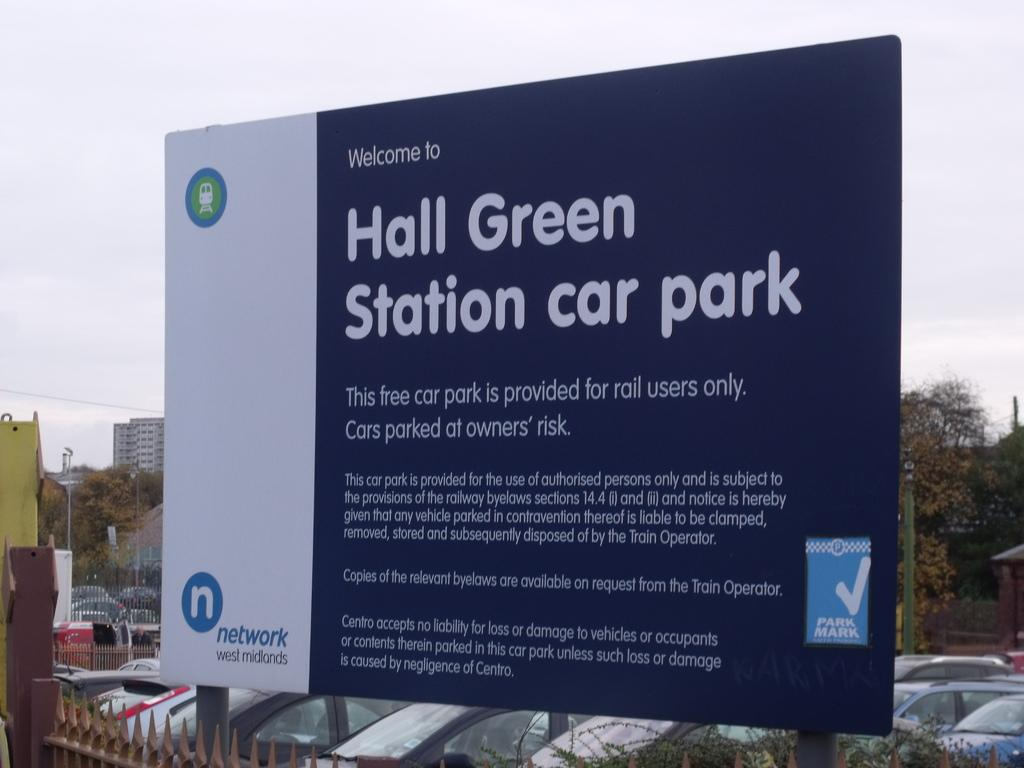What is the color scheme of the advertising board in the image? The advertising board in the image has a white and blue color scheme. What can be seen behind the advertising board? There are cars parked behind the advertising board. What type of natural scenery is visible in the background of the image? Trees are visible in the background of the image. Can you tell me how many strangers are using the calculator in the image? There is no calculator or stranger present in the image. What type of wire is connected to the advertising board in the image? There is no wire connected to the advertising board in the image. 